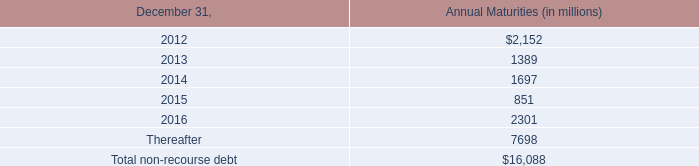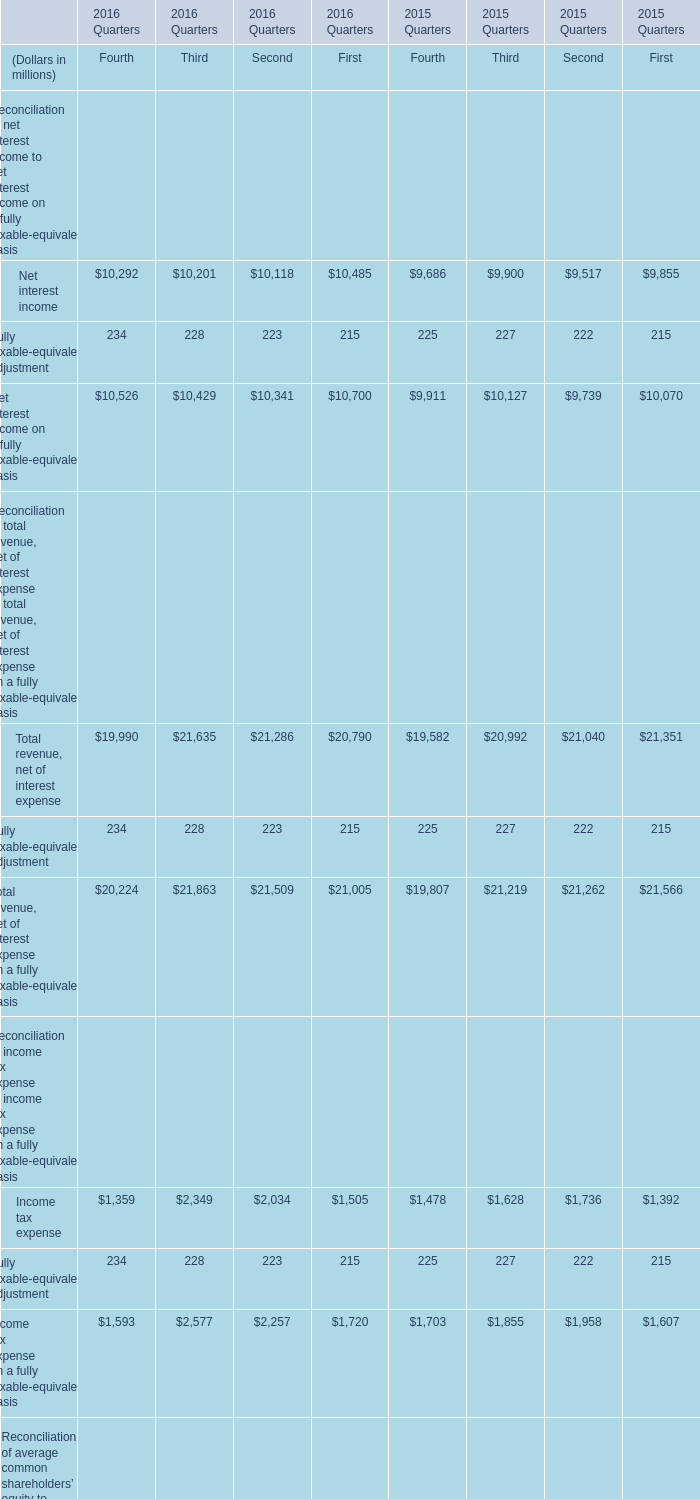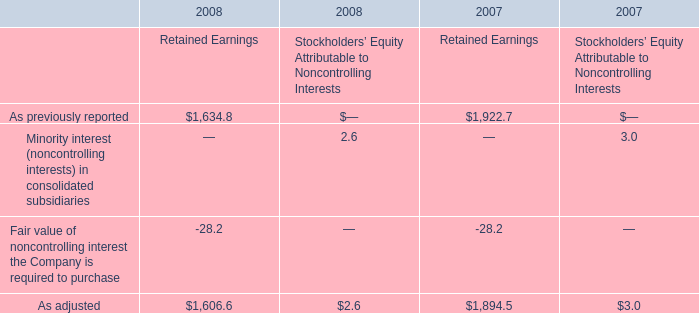What is the average amount of As adjusted of 2007 Retained Earnings, and Net interest income of 2015 Quarters Third ? 
Computations: ((1894.5 + 9900.0) / 2)
Answer: 5897.25. 